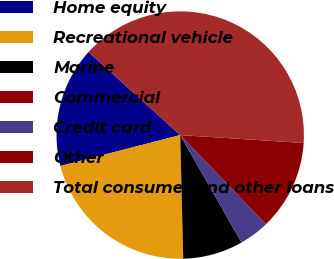Convert chart. <chart><loc_0><loc_0><loc_500><loc_500><pie_chart><fcel>Home equity<fcel>Recreational vehicle<fcel>Marine<fcel>Commercial<fcel>Credit card<fcel>Other<fcel>Total consumer and other loans<nl><fcel>15.73%<fcel>21.37%<fcel>7.86%<fcel>0.0%<fcel>3.93%<fcel>11.8%<fcel>39.31%<nl></chart> 